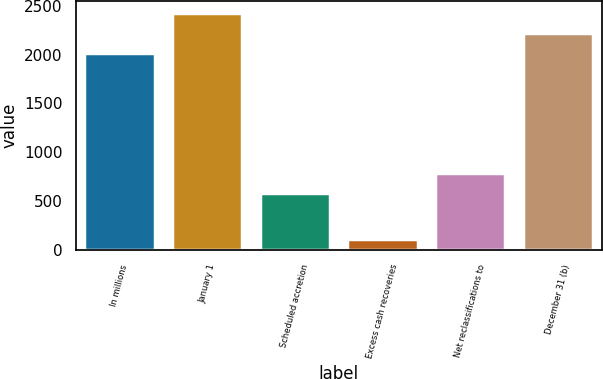<chart> <loc_0><loc_0><loc_500><loc_500><bar_chart><fcel>In millions<fcel>January 1<fcel>Scheduled accretion<fcel>Excess cash recoveries<fcel>Net reclassifications to<fcel>December 31 (b)<nl><fcel>2013<fcel>2423.2<fcel>580<fcel>115<fcel>785.1<fcel>2218.1<nl></chart> 